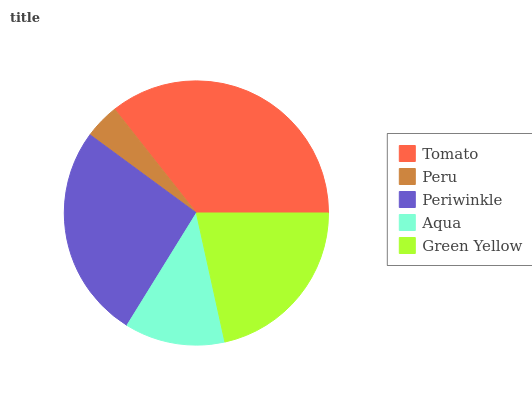Is Peru the minimum?
Answer yes or no. Yes. Is Tomato the maximum?
Answer yes or no. Yes. Is Periwinkle the minimum?
Answer yes or no. No. Is Periwinkle the maximum?
Answer yes or no. No. Is Periwinkle greater than Peru?
Answer yes or no. Yes. Is Peru less than Periwinkle?
Answer yes or no. Yes. Is Peru greater than Periwinkle?
Answer yes or no. No. Is Periwinkle less than Peru?
Answer yes or no. No. Is Green Yellow the high median?
Answer yes or no. Yes. Is Green Yellow the low median?
Answer yes or no. Yes. Is Tomato the high median?
Answer yes or no. No. Is Periwinkle the low median?
Answer yes or no. No. 